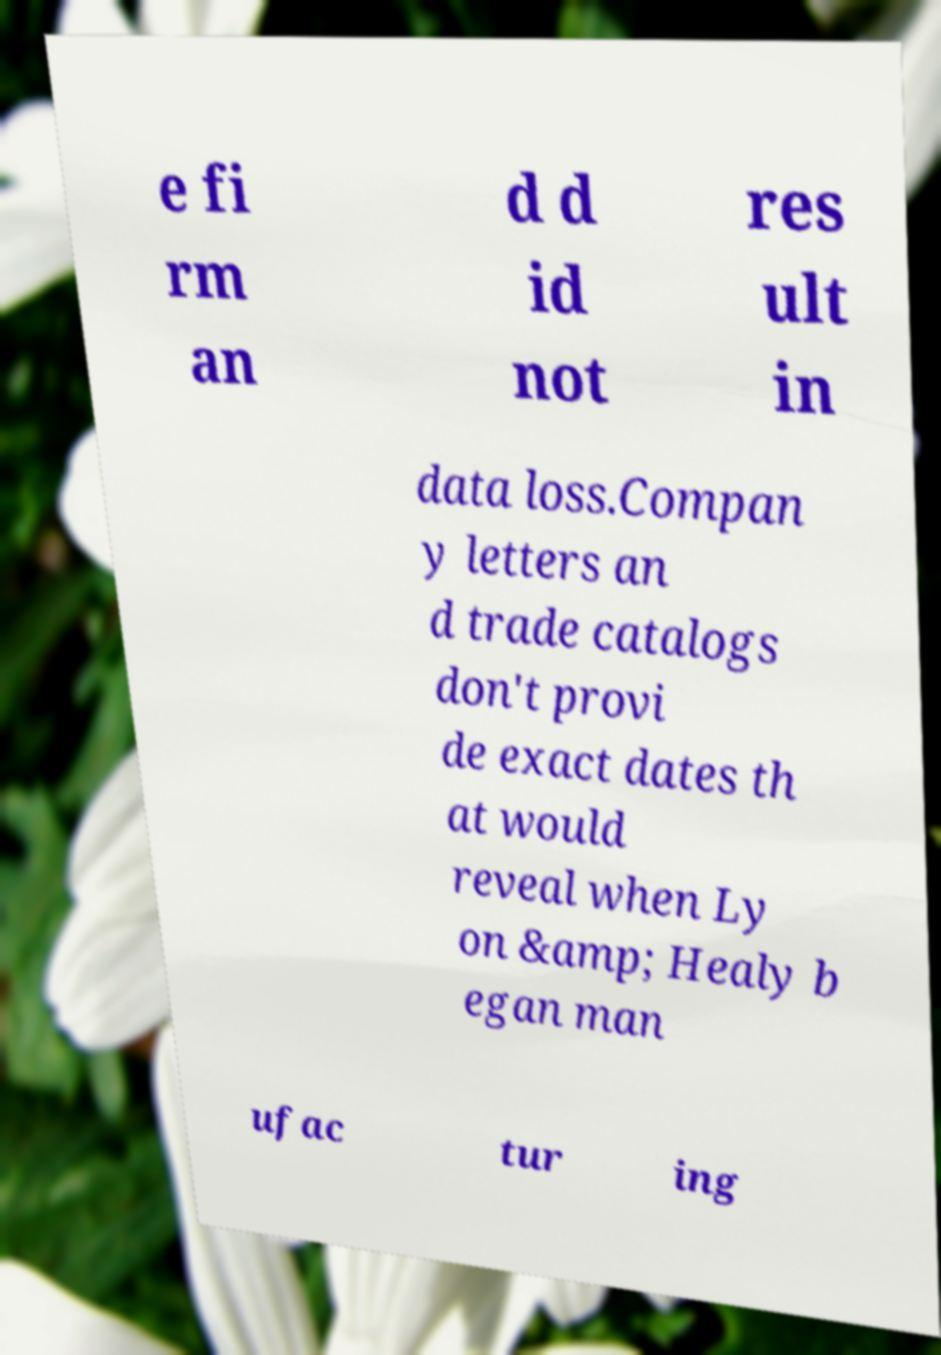Could you extract and type out the text from this image? e fi rm an d d id not res ult in data loss.Compan y letters an d trade catalogs don't provi de exact dates th at would reveal when Ly on &amp; Healy b egan man ufac tur ing 